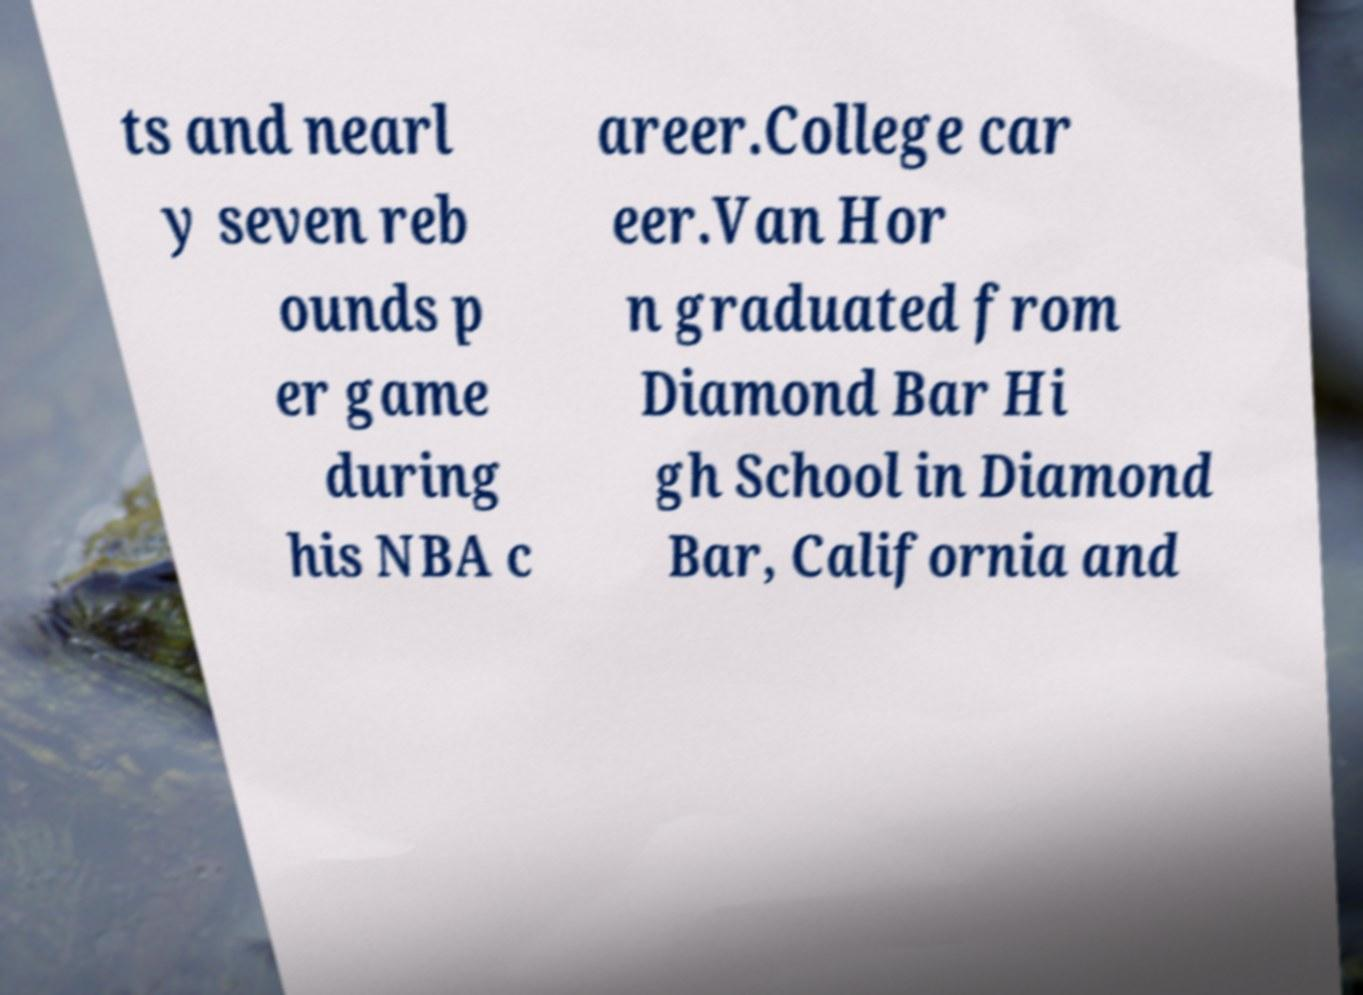Please read and relay the text visible in this image. What does it say? ts and nearl y seven reb ounds p er game during his NBA c areer.College car eer.Van Hor n graduated from Diamond Bar Hi gh School in Diamond Bar, California and 